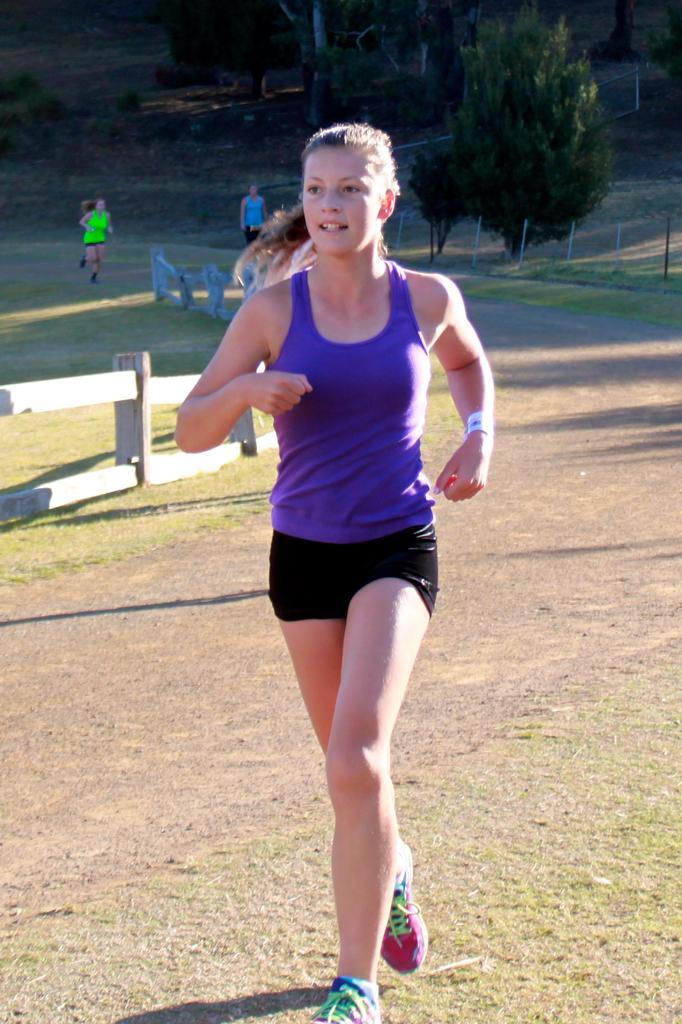In one or two sentences, can you explain what this image depicts? In this image in front there is a person running on the road. Behind her there are two other people. There is a fence. In the background of the image there are trees. 